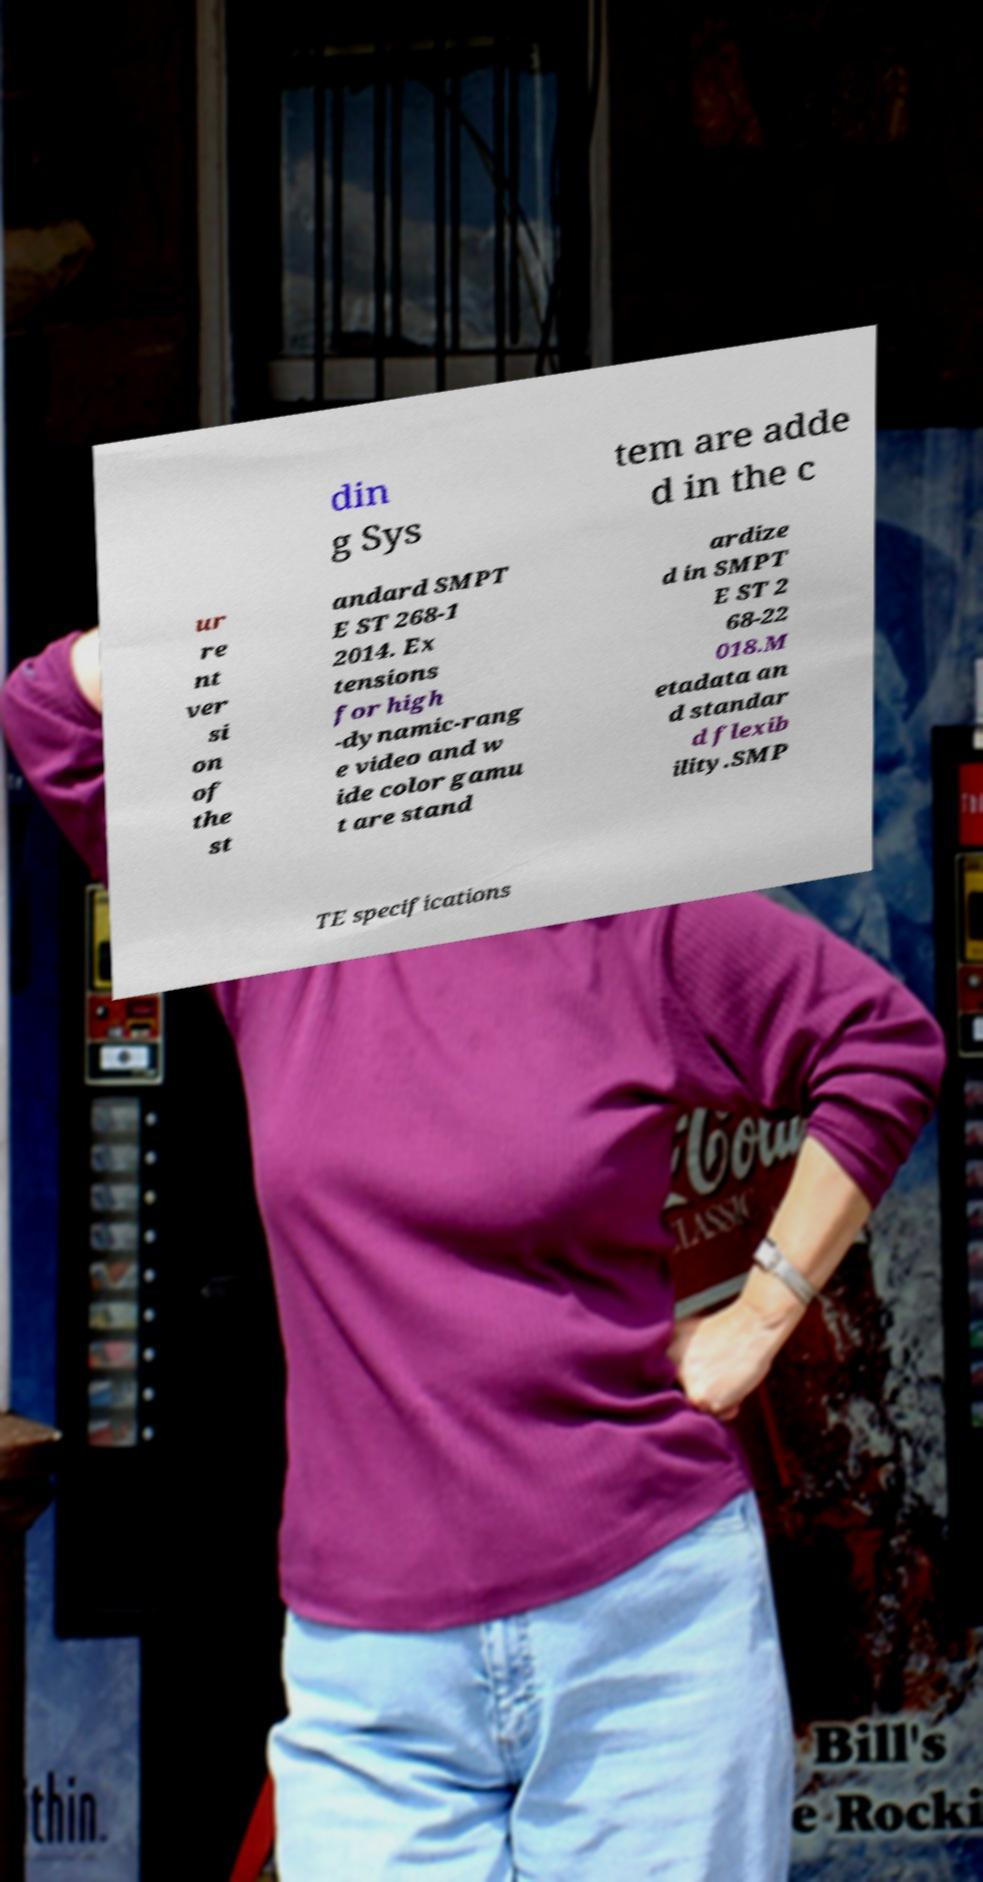Could you extract and type out the text from this image? din g Sys tem are adde d in the c ur re nt ver si on of the st andard SMPT E ST 268-1 2014. Ex tensions for high -dynamic-rang e video and w ide color gamu t are stand ardize d in SMPT E ST 2 68-22 018.M etadata an d standar d flexib ility.SMP TE specifications 